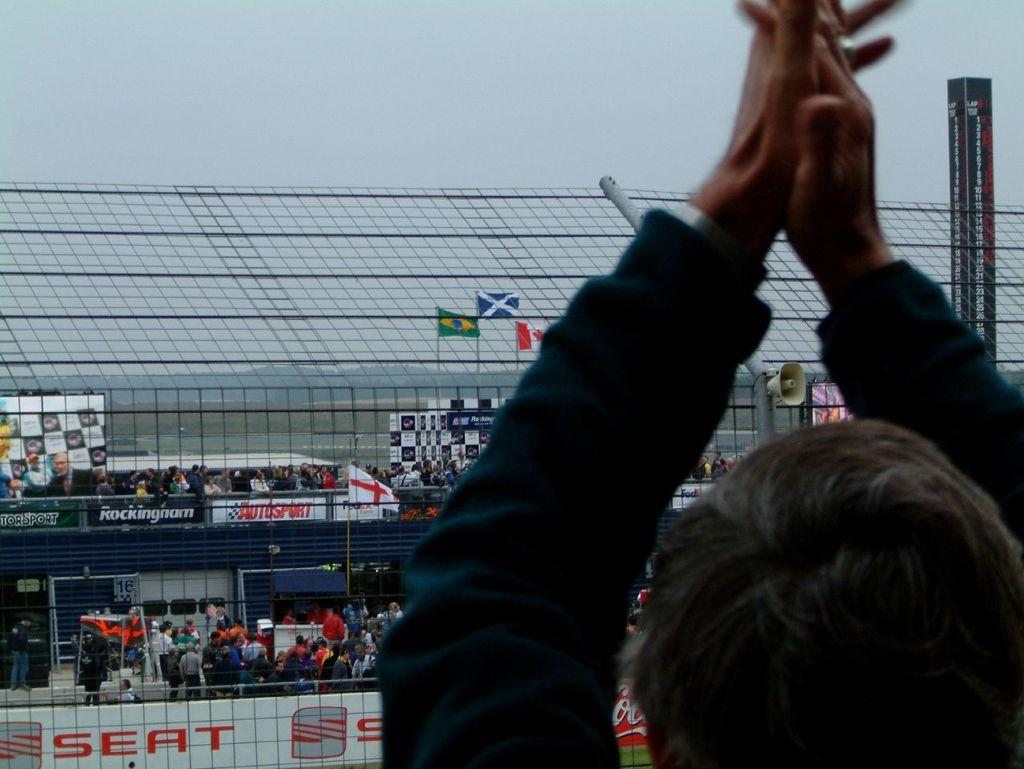What is the position of the person in the image? There is a person standing on the right side of the image. What can be seen in the image besides the person? There are flags, fencing, name boards, and the sky visible in the image. How many people are present in the image? There are people in the image, but the exact number is not specified. What is the purpose of the name boards in the image? The purpose of the name boards is not specified, but they are present in the image. What type of sugar is being served on the tray in the image? There is no tray or sugar present in the image. 